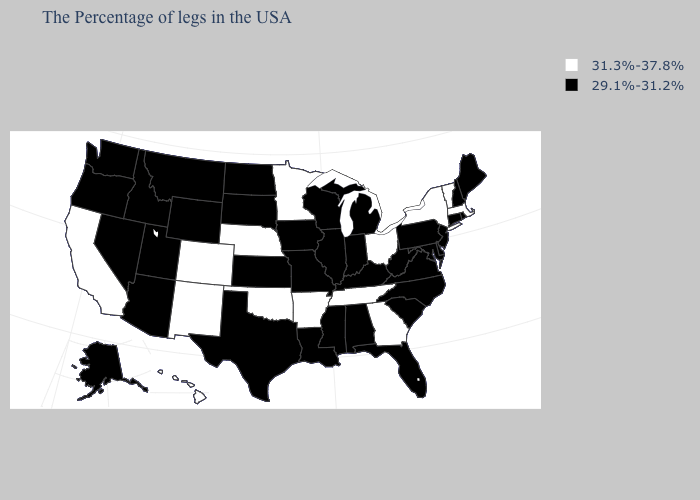What is the value of South Carolina?
Concise answer only. 29.1%-31.2%. Which states hav the highest value in the MidWest?
Short answer required. Ohio, Minnesota, Nebraska. Among the states that border Mississippi , which have the lowest value?
Quick response, please. Alabama, Louisiana. Name the states that have a value in the range 29.1%-31.2%?
Give a very brief answer. Maine, Rhode Island, New Hampshire, Connecticut, New Jersey, Delaware, Maryland, Pennsylvania, Virginia, North Carolina, South Carolina, West Virginia, Florida, Michigan, Kentucky, Indiana, Alabama, Wisconsin, Illinois, Mississippi, Louisiana, Missouri, Iowa, Kansas, Texas, South Dakota, North Dakota, Wyoming, Utah, Montana, Arizona, Idaho, Nevada, Washington, Oregon, Alaska. Name the states that have a value in the range 31.3%-37.8%?
Quick response, please. Massachusetts, Vermont, New York, Ohio, Georgia, Tennessee, Arkansas, Minnesota, Nebraska, Oklahoma, Colorado, New Mexico, California, Hawaii. What is the value of Hawaii?
Concise answer only. 31.3%-37.8%. What is the value of Michigan?
Answer briefly. 29.1%-31.2%. Does Washington have a lower value than Arkansas?
Write a very short answer. Yes. Name the states that have a value in the range 29.1%-31.2%?
Give a very brief answer. Maine, Rhode Island, New Hampshire, Connecticut, New Jersey, Delaware, Maryland, Pennsylvania, Virginia, North Carolina, South Carolina, West Virginia, Florida, Michigan, Kentucky, Indiana, Alabama, Wisconsin, Illinois, Mississippi, Louisiana, Missouri, Iowa, Kansas, Texas, South Dakota, North Dakota, Wyoming, Utah, Montana, Arizona, Idaho, Nevada, Washington, Oregon, Alaska. Which states have the lowest value in the South?
Be succinct. Delaware, Maryland, Virginia, North Carolina, South Carolina, West Virginia, Florida, Kentucky, Alabama, Mississippi, Louisiana, Texas. What is the value of West Virginia?
Concise answer only. 29.1%-31.2%. Name the states that have a value in the range 31.3%-37.8%?
Write a very short answer. Massachusetts, Vermont, New York, Ohio, Georgia, Tennessee, Arkansas, Minnesota, Nebraska, Oklahoma, Colorado, New Mexico, California, Hawaii. What is the value of South Dakota?
Quick response, please. 29.1%-31.2%. Does the first symbol in the legend represent the smallest category?
Answer briefly. No. 